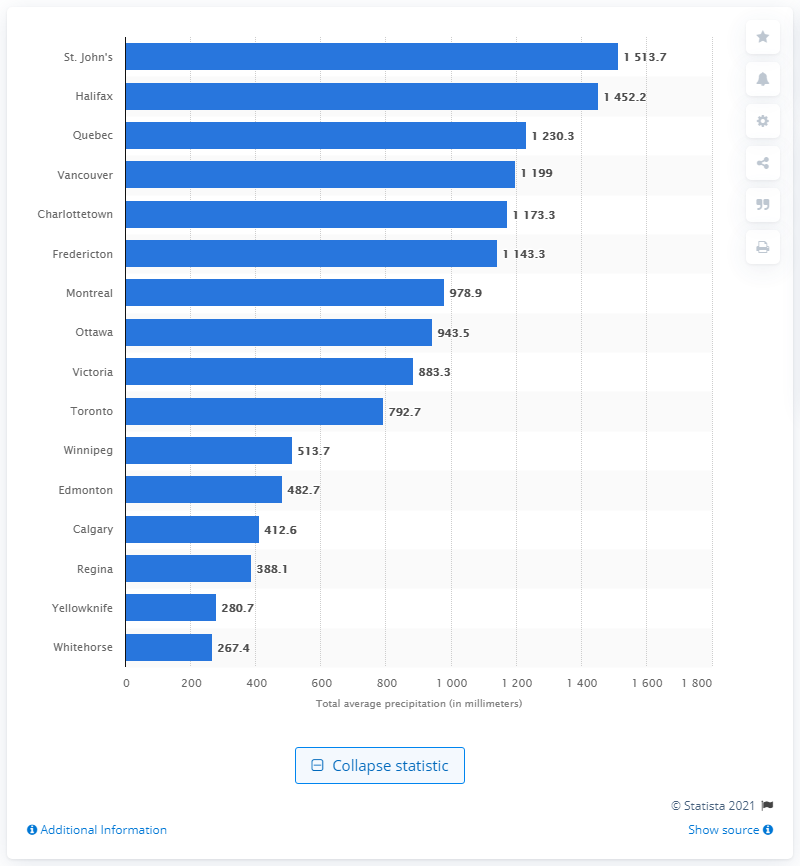Outline some significant characteristics in this image. From 1971 to 2000, the annual amount of precipitation in Victoria was 883.3 millimeters. During the period of 1971 to 2000, the city of Victoria in Canada received the most precipitation out of all cities in Canada. 